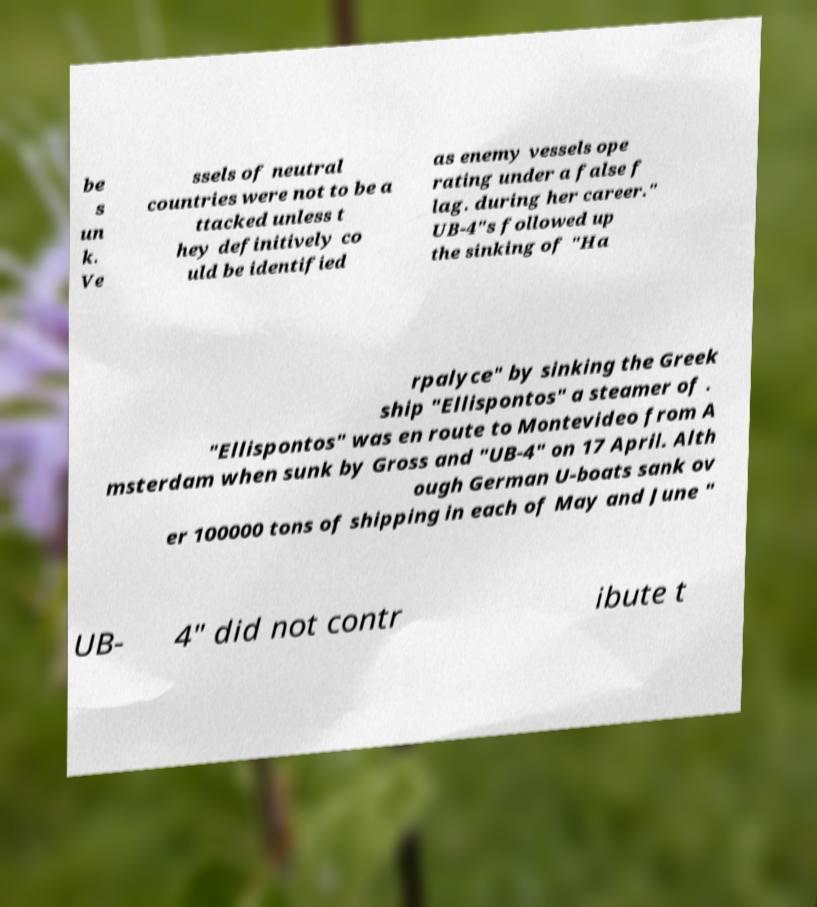Can you accurately transcribe the text from the provided image for me? be s un k. Ve ssels of neutral countries were not to be a ttacked unless t hey definitively co uld be identified as enemy vessels ope rating under a false f lag. during her career." UB-4"s followed up the sinking of "Ha rpalyce" by sinking the Greek ship "Ellispontos" a steamer of . "Ellispontos" was en route to Montevideo from A msterdam when sunk by Gross and "UB-4" on 17 April. Alth ough German U-boats sank ov er 100000 tons of shipping in each of May and June " UB- 4" did not contr ibute t 